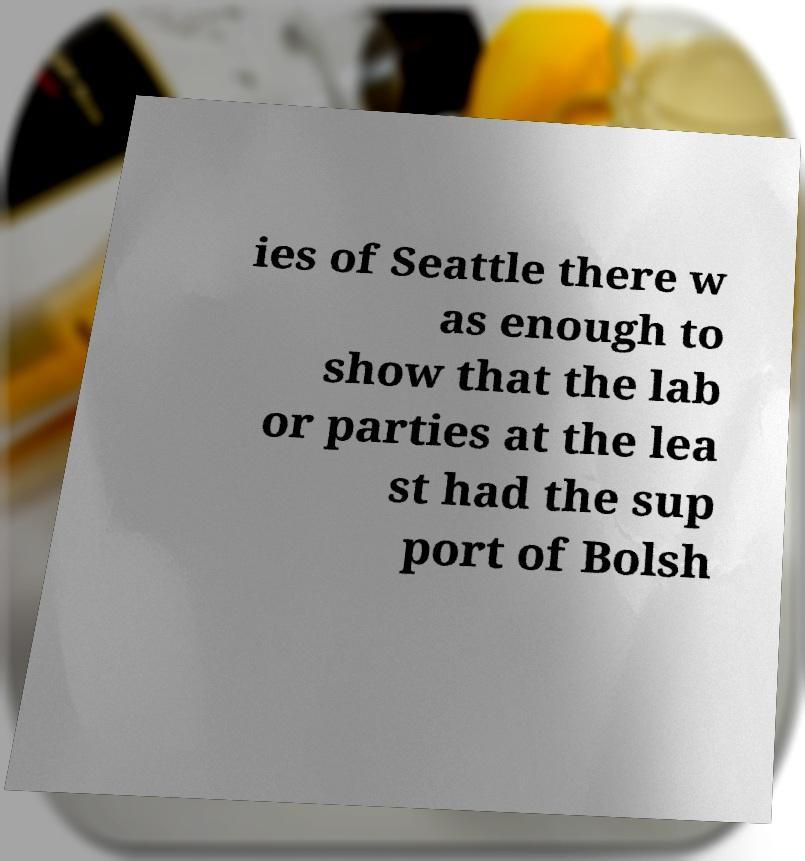There's text embedded in this image that I need extracted. Can you transcribe it verbatim? ies of Seattle there w as enough to show that the lab or parties at the lea st had the sup port of Bolsh 